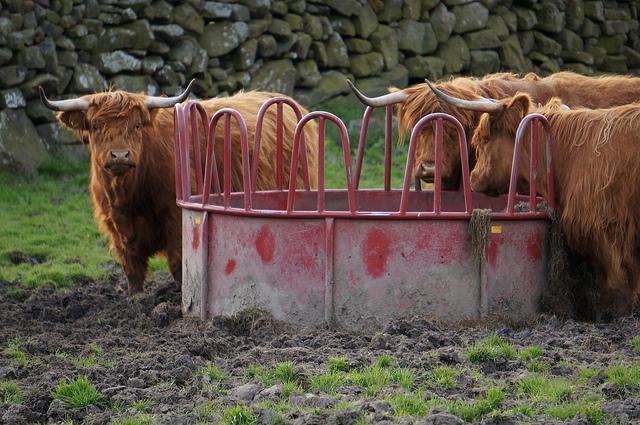Is this part of the animal known for being very sensitive?
Be succinct. No. Are these animals native to Iceland?
Give a very brief answer. Yes. Is this animal male or female?
Write a very short answer. Male. What color are these creatures?
Keep it brief. Brown. What kind of animals are these?
Short answer required. Bulls. Do you see a flower?
Write a very short answer. No. What color are the animals?
Quick response, please. Brown. Are the cows wearing any sort of identification?
Write a very short answer. No. Is this in a city?
Be succinct. No. How many cows in the picture?
Give a very brief answer. 3. What is the color of the animals?
Be succinct. Brown. Would you want these animals for pets?
Write a very short answer. No. Are the animals running?
Short answer required. No. What are these animals doing?
Give a very brief answer. Eating. 